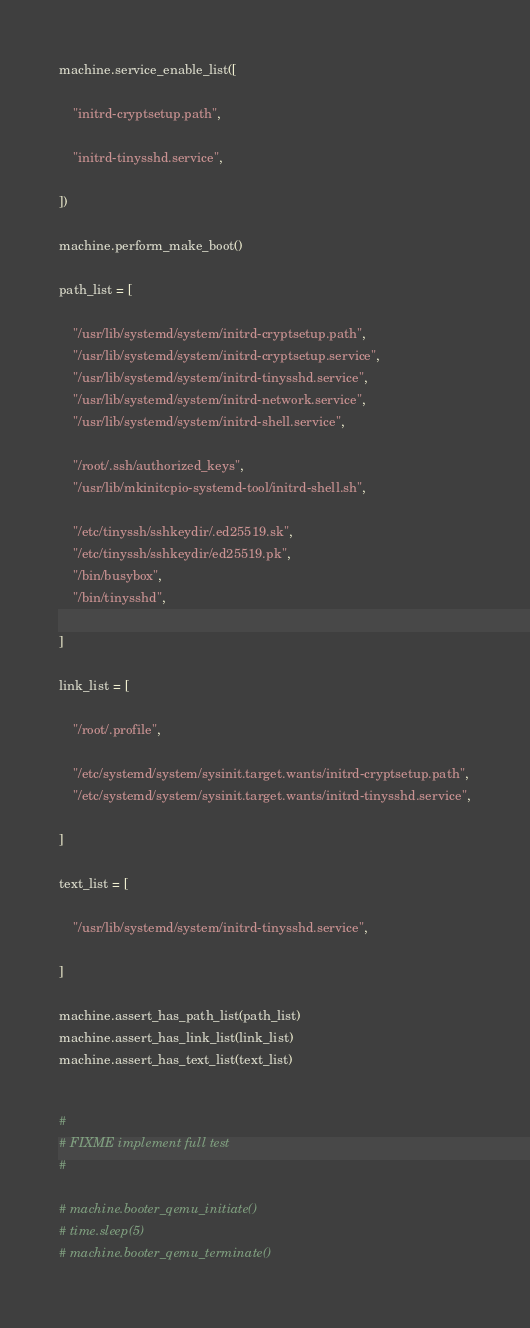Convert code to text. <code><loc_0><loc_0><loc_500><loc_500><_Python_>machine.service_enable_list([

    "initrd-cryptsetup.path",

    "initrd-tinysshd.service",

])

machine.perform_make_boot()

path_list = [

    "/usr/lib/systemd/system/initrd-cryptsetup.path",
    "/usr/lib/systemd/system/initrd-cryptsetup.service",
    "/usr/lib/systemd/system/initrd-tinysshd.service",
    "/usr/lib/systemd/system/initrd-network.service",
    "/usr/lib/systemd/system/initrd-shell.service",

    "/root/.ssh/authorized_keys",
    "/usr/lib/mkinitcpio-systemd-tool/initrd-shell.sh",

    "/etc/tinyssh/sshkeydir/.ed25519.sk",
    "/etc/tinyssh/sshkeydir/ed25519.pk",
    "/bin/busybox",
    "/bin/tinysshd",

]

link_list = [

    "/root/.profile",

    "/etc/systemd/system/sysinit.target.wants/initrd-cryptsetup.path",
    "/etc/systemd/system/sysinit.target.wants/initrd-tinysshd.service",

]

text_list = [

    "/usr/lib/systemd/system/initrd-tinysshd.service",

]

machine.assert_has_path_list(path_list)
machine.assert_has_link_list(link_list)
machine.assert_has_text_list(text_list)


#
# FIXME implement full test
#

# machine.booter_qemu_initiate()
# time.sleep(5)
# machine.booter_qemu_terminate()
</code> 